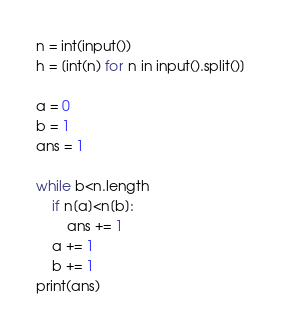Convert code to text. <code><loc_0><loc_0><loc_500><loc_500><_Python_>n = int(input())
h = [int(n) for n in input().split()]

a = 0
b = 1
ans = 1

while b<n.length
    if n[a]<n[b]:
        ans += 1
    a += 1
    b += 1
print(ans)</code> 